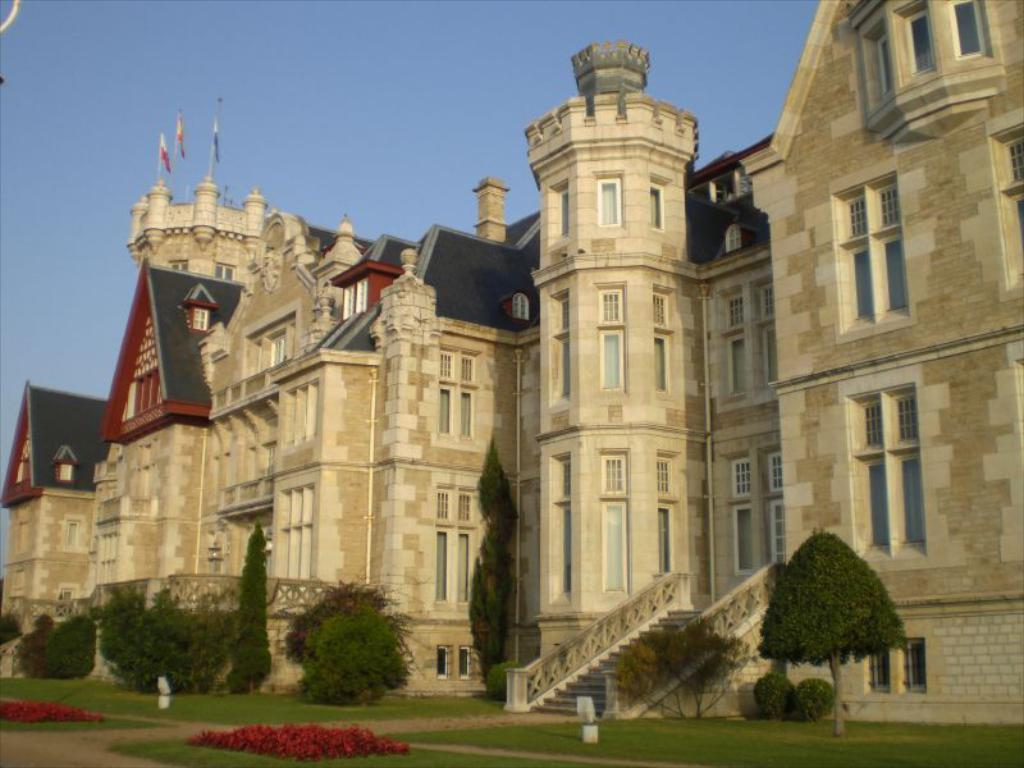What type of vegetation can be seen in the image? There is grass, plants, and trees visible in the image. What architectural feature is present in the image? There is a staircase in the image. What type of structures are visible in the image? There are buildings in the image. What can be seen on the buildings in the image? There are windows visible on the buildings. What is located at the top of the image? There are flags and the sky visible at the top of the image. Can you determine the time of day the image was taken? The image is likely taken during the day, as the sky is visible and not dark. What advertisement can be seen on the grass in the image? There is no advertisement visible on the grass in the image. Can you see a person breathing in the image? There is no person present in the image, so it is not possible to see someone breathing. 